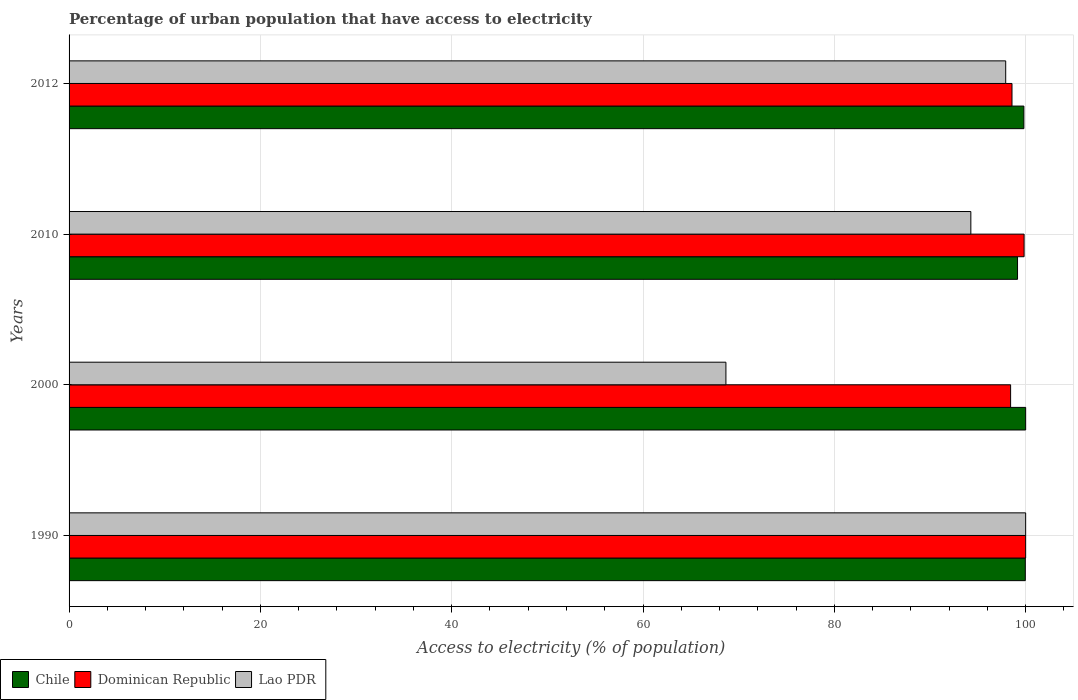How many different coloured bars are there?
Provide a short and direct response. 3. How many groups of bars are there?
Your answer should be very brief. 4. Are the number of bars on each tick of the Y-axis equal?
Your answer should be very brief. Yes. How many bars are there on the 4th tick from the bottom?
Offer a very short reply. 3. What is the label of the 1st group of bars from the top?
Give a very brief answer. 2012. Across all years, what is the minimum percentage of urban population that have access to electricity in Chile?
Your answer should be very brief. 99.15. In which year was the percentage of urban population that have access to electricity in Chile minimum?
Ensure brevity in your answer.  2010. What is the total percentage of urban population that have access to electricity in Chile in the graph?
Ensure brevity in your answer.  398.93. What is the difference between the percentage of urban population that have access to electricity in Chile in 1990 and that in 2012?
Offer a terse response. 0.15. What is the difference between the percentage of urban population that have access to electricity in Lao PDR in 1990 and the percentage of urban population that have access to electricity in Dominican Republic in 2010?
Offer a terse response. 0.16. What is the average percentage of urban population that have access to electricity in Chile per year?
Ensure brevity in your answer.  99.73. What is the ratio of the percentage of urban population that have access to electricity in Lao PDR in 2010 to that in 2012?
Your answer should be compact. 0.96. Is the difference between the percentage of urban population that have access to electricity in Dominican Republic in 1990 and 2012 greater than the difference between the percentage of urban population that have access to electricity in Lao PDR in 1990 and 2012?
Your answer should be compact. No. What is the difference between the highest and the second highest percentage of urban population that have access to electricity in Dominican Republic?
Your answer should be compact. 0.16. What is the difference between the highest and the lowest percentage of urban population that have access to electricity in Dominican Republic?
Your answer should be very brief. 1.57. In how many years, is the percentage of urban population that have access to electricity in Chile greater than the average percentage of urban population that have access to electricity in Chile taken over all years?
Give a very brief answer. 3. Is the sum of the percentage of urban population that have access to electricity in Lao PDR in 1990 and 2000 greater than the maximum percentage of urban population that have access to electricity in Chile across all years?
Provide a short and direct response. Yes. What does the 2nd bar from the top in 2010 represents?
Offer a very short reply. Dominican Republic. What does the 3rd bar from the bottom in 2000 represents?
Ensure brevity in your answer.  Lao PDR. Are all the bars in the graph horizontal?
Offer a terse response. Yes. How many years are there in the graph?
Give a very brief answer. 4. What is the difference between two consecutive major ticks on the X-axis?
Provide a succinct answer. 20. Where does the legend appear in the graph?
Offer a terse response. Bottom left. How many legend labels are there?
Your answer should be very brief. 3. How are the legend labels stacked?
Offer a terse response. Horizontal. What is the title of the graph?
Offer a very short reply. Percentage of urban population that have access to electricity. What is the label or title of the X-axis?
Your answer should be very brief. Access to electricity (% of population). What is the Access to electricity (% of population) of Chile in 1990?
Make the answer very short. 99.96. What is the Access to electricity (% of population) of Lao PDR in 1990?
Offer a terse response. 100. What is the Access to electricity (% of population) of Chile in 2000?
Offer a terse response. 100. What is the Access to electricity (% of population) in Dominican Republic in 2000?
Your response must be concise. 98.43. What is the Access to electricity (% of population) in Lao PDR in 2000?
Offer a terse response. 68.67. What is the Access to electricity (% of population) in Chile in 2010?
Offer a very short reply. 99.15. What is the Access to electricity (% of population) of Dominican Republic in 2010?
Keep it short and to the point. 99.84. What is the Access to electricity (% of population) in Lao PDR in 2010?
Offer a very short reply. 94.27. What is the Access to electricity (% of population) of Chile in 2012?
Keep it short and to the point. 99.81. What is the Access to electricity (% of population) of Dominican Republic in 2012?
Provide a short and direct response. 98.57. What is the Access to electricity (% of population) in Lao PDR in 2012?
Offer a very short reply. 97.91. Across all years, what is the minimum Access to electricity (% of population) of Chile?
Provide a succinct answer. 99.15. Across all years, what is the minimum Access to electricity (% of population) in Dominican Republic?
Make the answer very short. 98.43. Across all years, what is the minimum Access to electricity (% of population) in Lao PDR?
Your answer should be very brief. 68.67. What is the total Access to electricity (% of population) in Chile in the graph?
Your answer should be compact. 398.93. What is the total Access to electricity (% of population) of Dominican Republic in the graph?
Provide a succinct answer. 396.83. What is the total Access to electricity (% of population) in Lao PDR in the graph?
Ensure brevity in your answer.  360.85. What is the difference between the Access to electricity (% of population) in Chile in 1990 and that in 2000?
Offer a terse response. -0.04. What is the difference between the Access to electricity (% of population) of Dominican Republic in 1990 and that in 2000?
Provide a succinct answer. 1.57. What is the difference between the Access to electricity (% of population) in Lao PDR in 1990 and that in 2000?
Your answer should be compact. 31.33. What is the difference between the Access to electricity (% of population) in Chile in 1990 and that in 2010?
Ensure brevity in your answer.  0.81. What is the difference between the Access to electricity (% of population) in Dominican Republic in 1990 and that in 2010?
Make the answer very short. 0.16. What is the difference between the Access to electricity (% of population) in Lao PDR in 1990 and that in 2010?
Offer a very short reply. 5.73. What is the difference between the Access to electricity (% of population) of Chile in 1990 and that in 2012?
Offer a very short reply. 0.15. What is the difference between the Access to electricity (% of population) in Dominican Republic in 1990 and that in 2012?
Offer a very short reply. 1.43. What is the difference between the Access to electricity (% of population) in Lao PDR in 1990 and that in 2012?
Keep it short and to the point. 2.09. What is the difference between the Access to electricity (% of population) in Chile in 2000 and that in 2010?
Your answer should be compact. 0.85. What is the difference between the Access to electricity (% of population) in Dominican Republic in 2000 and that in 2010?
Your response must be concise. -1.41. What is the difference between the Access to electricity (% of population) in Lao PDR in 2000 and that in 2010?
Offer a terse response. -25.6. What is the difference between the Access to electricity (% of population) of Chile in 2000 and that in 2012?
Offer a very short reply. 0.19. What is the difference between the Access to electricity (% of population) of Dominican Republic in 2000 and that in 2012?
Offer a very short reply. -0.15. What is the difference between the Access to electricity (% of population) of Lao PDR in 2000 and that in 2012?
Give a very brief answer. -29.25. What is the difference between the Access to electricity (% of population) of Chile in 2010 and that in 2012?
Provide a short and direct response. -0.67. What is the difference between the Access to electricity (% of population) in Dominican Republic in 2010 and that in 2012?
Keep it short and to the point. 1.26. What is the difference between the Access to electricity (% of population) of Lao PDR in 2010 and that in 2012?
Ensure brevity in your answer.  -3.64. What is the difference between the Access to electricity (% of population) of Chile in 1990 and the Access to electricity (% of population) of Dominican Republic in 2000?
Ensure brevity in your answer.  1.54. What is the difference between the Access to electricity (% of population) of Chile in 1990 and the Access to electricity (% of population) of Lao PDR in 2000?
Ensure brevity in your answer.  31.3. What is the difference between the Access to electricity (% of population) in Dominican Republic in 1990 and the Access to electricity (% of population) in Lao PDR in 2000?
Keep it short and to the point. 31.33. What is the difference between the Access to electricity (% of population) in Chile in 1990 and the Access to electricity (% of population) in Dominican Republic in 2010?
Offer a terse response. 0.13. What is the difference between the Access to electricity (% of population) of Chile in 1990 and the Access to electricity (% of population) of Lao PDR in 2010?
Give a very brief answer. 5.69. What is the difference between the Access to electricity (% of population) in Dominican Republic in 1990 and the Access to electricity (% of population) in Lao PDR in 2010?
Offer a very short reply. 5.73. What is the difference between the Access to electricity (% of population) in Chile in 1990 and the Access to electricity (% of population) in Dominican Republic in 2012?
Your answer should be compact. 1.39. What is the difference between the Access to electricity (% of population) of Chile in 1990 and the Access to electricity (% of population) of Lao PDR in 2012?
Your response must be concise. 2.05. What is the difference between the Access to electricity (% of population) in Dominican Republic in 1990 and the Access to electricity (% of population) in Lao PDR in 2012?
Keep it short and to the point. 2.09. What is the difference between the Access to electricity (% of population) in Chile in 2000 and the Access to electricity (% of population) in Dominican Republic in 2010?
Offer a very short reply. 0.16. What is the difference between the Access to electricity (% of population) of Chile in 2000 and the Access to electricity (% of population) of Lao PDR in 2010?
Make the answer very short. 5.73. What is the difference between the Access to electricity (% of population) of Dominican Republic in 2000 and the Access to electricity (% of population) of Lao PDR in 2010?
Your answer should be very brief. 4.16. What is the difference between the Access to electricity (% of population) in Chile in 2000 and the Access to electricity (% of population) in Dominican Republic in 2012?
Give a very brief answer. 1.43. What is the difference between the Access to electricity (% of population) of Chile in 2000 and the Access to electricity (% of population) of Lao PDR in 2012?
Provide a short and direct response. 2.09. What is the difference between the Access to electricity (% of population) in Dominican Republic in 2000 and the Access to electricity (% of population) in Lao PDR in 2012?
Offer a terse response. 0.51. What is the difference between the Access to electricity (% of population) in Chile in 2010 and the Access to electricity (% of population) in Dominican Republic in 2012?
Your response must be concise. 0.58. What is the difference between the Access to electricity (% of population) of Chile in 2010 and the Access to electricity (% of population) of Lao PDR in 2012?
Your answer should be very brief. 1.24. What is the difference between the Access to electricity (% of population) of Dominican Republic in 2010 and the Access to electricity (% of population) of Lao PDR in 2012?
Keep it short and to the point. 1.92. What is the average Access to electricity (% of population) of Chile per year?
Make the answer very short. 99.73. What is the average Access to electricity (% of population) in Dominican Republic per year?
Make the answer very short. 99.21. What is the average Access to electricity (% of population) of Lao PDR per year?
Offer a terse response. 90.21. In the year 1990, what is the difference between the Access to electricity (% of population) in Chile and Access to electricity (% of population) in Dominican Republic?
Provide a short and direct response. -0.04. In the year 1990, what is the difference between the Access to electricity (% of population) of Chile and Access to electricity (% of population) of Lao PDR?
Give a very brief answer. -0.04. In the year 2000, what is the difference between the Access to electricity (% of population) of Chile and Access to electricity (% of population) of Dominican Republic?
Your answer should be compact. 1.57. In the year 2000, what is the difference between the Access to electricity (% of population) in Chile and Access to electricity (% of population) in Lao PDR?
Ensure brevity in your answer.  31.33. In the year 2000, what is the difference between the Access to electricity (% of population) of Dominican Republic and Access to electricity (% of population) of Lao PDR?
Your answer should be very brief. 29.76. In the year 2010, what is the difference between the Access to electricity (% of population) in Chile and Access to electricity (% of population) in Dominican Republic?
Provide a succinct answer. -0.69. In the year 2010, what is the difference between the Access to electricity (% of population) in Chile and Access to electricity (% of population) in Lao PDR?
Offer a very short reply. 4.88. In the year 2010, what is the difference between the Access to electricity (% of population) of Dominican Republic and Access to electricity (% of population) of Lao PDR?
Ensure brevity in your answer.  5.57. In the year 2012, what is the difference between the Access to electricity (% of population) in Chile and Access to electricity (% of population) in Dominican Republic?
Keep it short and to the point. 1.24. In the year 2012, what is the difference between the Access to electricity (% of population) of Chile and Access to electricity (% of population) of Lao PDR?
Offer a terse response. 1.9. In the year 2012, what is the difference between the Access to electricity (% of population) in Dominican Republic and Access to electricity (% of population) in Lao PDR?
Your answer should be compact. 0.66. What is the ratio of the Access to electricity (% of population) in Dominican Republic in 1990 to that in 2000?
Offer a very short reply. 1.02. What is the ratio of the Access to electricity (% of population) in Lao PDR in 1990 to that in 2000?
Your answer should be very brief. 1.46. What is the ratio of the Access to electricity (% of population) of Chile in 1990 to that in 2010?
Provide a short and direct response. 1.01. What is the ratio of the Access to electricity (% of population) of Lao PDR in 1990 to that in 2010?
Your answer should be compact. 1.06. What is the ratio of the Access to electricity (% of population) in Dominican Republic in 1990 to that in 2012?
Offer a very short reply. 1.01. What is the ratio of the Access to electricity (% of population) in Lao PDR in 1990 to that in 2012?
Your answer should be very brief. 1.02. What is the ratio of the Access to electricity (% of population) in Chile in 2000 to that in 2010?
Provide a short and direct response. 1.01. What is the ratio of the Access to electricity (% of population) in Dominican Republic in 2000 to that in 2010?
Give a very brief answer. 0.99. What is the ratio of the Access to electricity (% of population) in Lao PDR in 2000 to that in 2010?
Your answer should be compact. 0.73. What is the ratio of the Access to electricity (% of population) of Lao PDR in 2000 to that in 2012?
Offer a terse response. 0.7. What is the ratio of the Access to electricity (% of population) of Chile in 2010 to that in 2012?
Keep it short and to the point. 0.99. What is the ratio of the Access to electricity (% of population) in Dominican Republic in 2010 to that in 2012?
Your response must be concise. 1.01. What is the ratio of the Access to electricity (% of population) of Lao PDR in 2010 to that in 2012?
Offer a terse response. 0.96. What is the difference between the highest and the second highest Access to electricity (% of population) of Chile?
Offer a very short reply. 0.04. What is the difference between the highest and the second highest Access to electricity (% of population) in Dominican Republic?
Offer a terse response. 0.16. What is the difference between the highest and the second highest Access to electricity (% of population) in Lao PDR?
Make the answer very short. 2.09. What is the difference between the highest and the lowest Access to electricity (% of population) of Chile?
Provide a short and direct response. 0.85. What is the difference between the highest and the lowest Access to electricity (% of population) in Dominican Republic?
Offer a very short reply. 1.57. What is the difference between the highest and the lowest Access to electricity (% of population) of Lao PDR?
Your response must be concise. 31.33. 